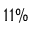Convert formula to latex. <formula><loc_0><loc_0><loc_500><loc_500>1 1 \%</formula> 